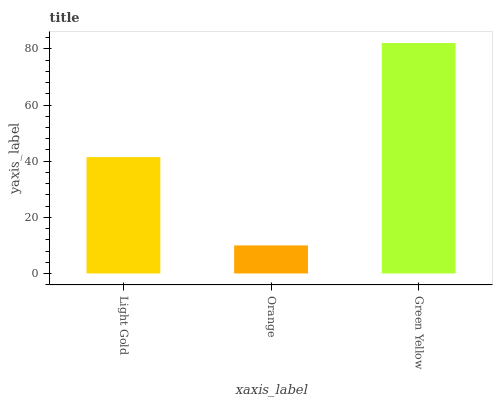Is Orange the minimum?
Answer yes or no. Yes. Is Green Yellow the maximum?
Answer yes or no. Yes. Is Green Yellow the minimum?
Answer yes or no. No. Is Orange the maximum?
Answer yes or no. No. Is Green Yellow greater than Orange?
Answer yes or no. Yes. Is Orange less than Green Yellow?
Answer yes or no. Yes. Is Orange greater than Green Yellow?
Answer yes or no. No. Is Green Yellow less than Orange?
Answer yes or no. No. Is Light Gold the high median?
Answer yes or no. Yes. Is Light Gold the low median?
Answer yes or no. Yes. Is Green Yellow the high median?
Answer yes or no. No. Is Orange the low median?
Answer yes or no. No. 